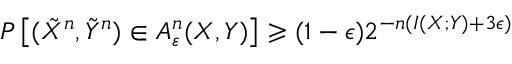Convert formula to latex. <formula><loc_0><loc_0><loc_500><loc_500>P \left [ ( { \tilde { X } } ^ { n } , { \tilde { Y } } ^ { n } ) \in A _ { \varepsilon } ^ { n } ( X , Y ) \right ] \geqslant ( 1 - \epsilon ) 2 ^ { - n ( I ( X ; Y ) + 3 \epsilon ) }</formula> 